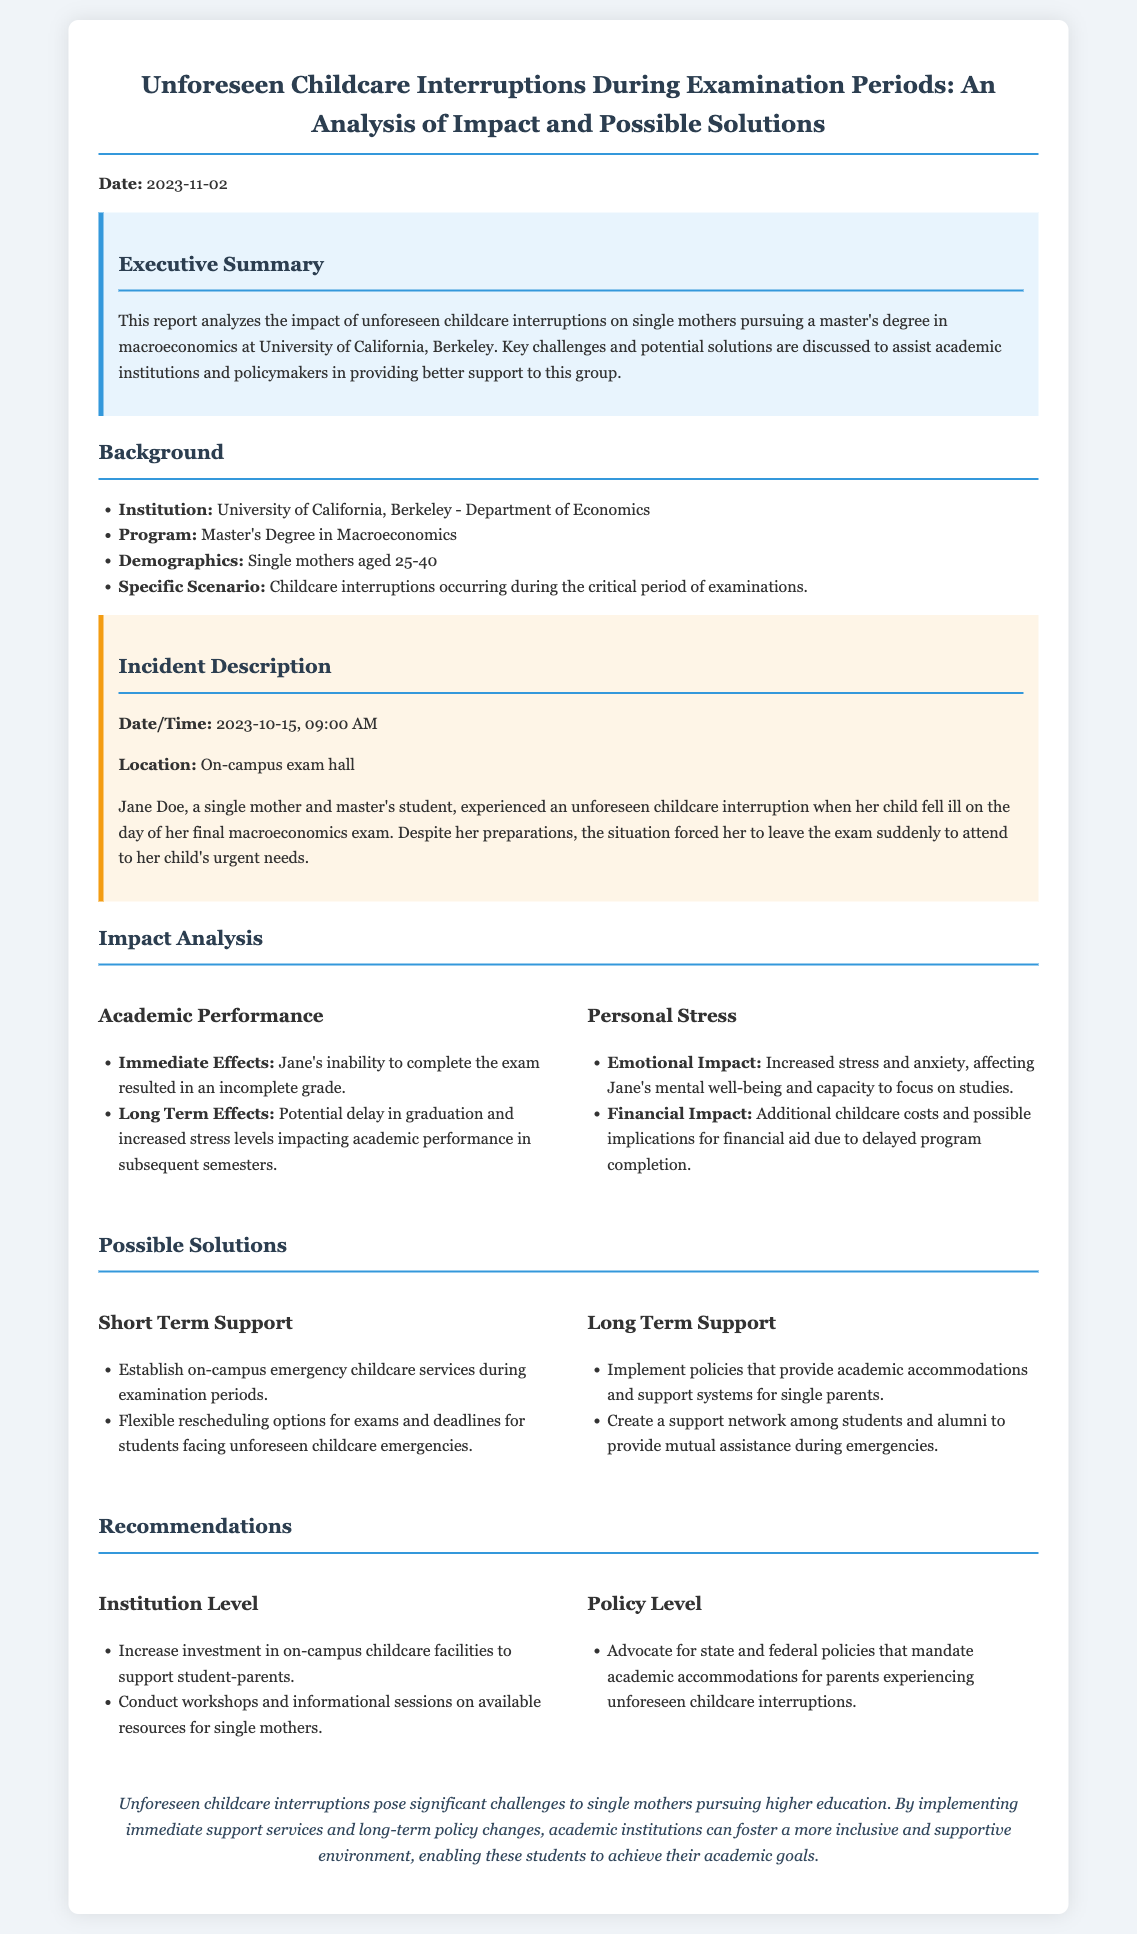what is the date of the report? The date of the report is mentioned at the beginning of the document.
Answer: 2023-11-02 who is the affected student mentioned in the incident description? The incident description specifies the name of the affected student as Jane Doe.
Answer: Jane Doe what was the specific date and time of the incident? The date and time of the incident are provided in the incident description section.
Answer: 2023-10-15, 09:00 AM what is one of the short-term support solutions suggested? The possible solutions section lists various supports, including one for short-term help.
Answer: Establish on-campus emergency childcare services during examination periods what are the emotional impacts mentioned in the impact analysis? The impact analysis section discusses various impacts, including emotional.
Answer: Increased stress and anxiety what is the long-term impact mentioned related to academic performance? The impact analysis mentions potential consequences regarding graduation timelines.
Answer: Potential delay in graduation which institution is the report focused on? The background section specifies the institution discussed in the report.
Answer: University of California, Berkeley what type of degree is being pursued by the single mothers? The background section outlines the type of degree being pursued by the demographic in focus.
Answer: Master's Degree in Macroeconomics what is a recommendation at the institution level? The recommendations section provides various suggestions for institutional level changes.
Answer: Increase investment in on-campus childcare facilities to support student-parents 